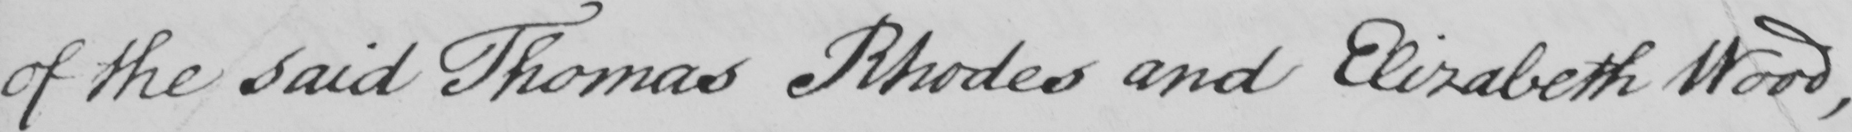Can you tell me what this handwritten text says? of the said Thomas Rhodes and Elizabeth Wood , 